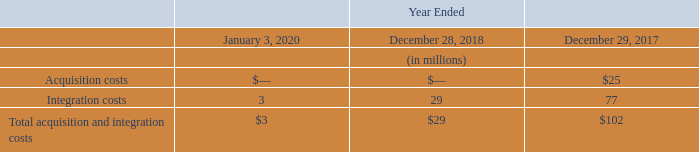Lockheed Martin Transaction
On August 16, 2016, a wholly-owned subsidiary of Leidos Holdings, Inc. merged with the IS&GS Business in a Reverse Morris Trust transaction (the "IS&GS Transactions").
During fiscal 2017, the Company recorded adjustments to finalize the fair value of acquired assets and liabilities assumed which resulted in a $337 million increase in goodwill. Significant changes included intangible assets, property, plant and equipment, deferred tax assets, other assets, accounts payable and accrued liabilities and deferred tax liabilities.
On January 10, 2018, the final amount of the net working capital of the IS&GS Business was determined through a binding arbitration proceeding in accordance with the Separation Agreement with Lockheed Martin. As a result, $24 million was recorded as acquisition costs in the consolidated statements of income for fiscal 2017. On January 18, 2018, the final working capital amount of $105 million was paid to Lockheed Martin, of which $24 million and $81 million was presented as cash flows from operating and investing activities, respectively, on the consolidated statements of cash flows.
During fiscal 2018, a tax indemnification liability of $23 million was paid to Lockheed Martin in accordance with the Tax Matters Agreement, which was presented as cash flows from financing activities on the consolidated statements of cash flows.
The Company incurred the following expenses related to the acquisition and integration of the IS&GS Business:
These acquisition and integration costs have been recorded within Corporate and presented in "Acquisition, integration and restructuring costs" on the consolidated statements of income.
What was the increase in goodwill in 2017? $337 million. What was the acquisition costs in the consolidated statements of income for fiscal 2017? $24 million. What was the Integration costs in 2020, 2018 and 2017 respectively?
Answer scale should be: million. 3, 29, 77. In which year was Integration costs more than 20 million? Locate and analyze integration costs in row 6
answer: 2018, 2017. What was the change in the Total acquisition and integration costs from 2017 to 2018?
Answer scale should be: million. 29 - 102
Answer: -73. What was the average Acquisition costs for 2017, 2018 and 2020?
Answer scale should be: million. (0 + 0 + 25) / 3
Answer: 8.33. 